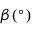<formula> <loc_0><loc_0><loc_500><loc_500>\beta ( ^ { \circ } )</formula> 